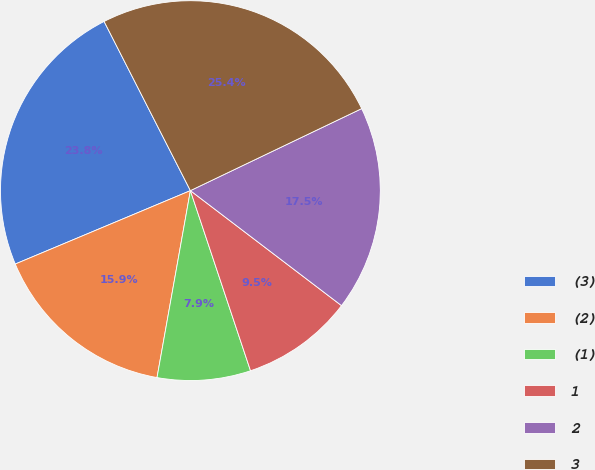<chart> <loc_0><loc_0><loc_500><loc_500><pie_chart><fcel>(3)<fcel>(2)<fcel>(1)<fcel>1<fcel>2<fcel>3<nl><fcel>23.81%<fcel>15.87%<fcel>7.94%<fcel>9.52%<fcel>17.46%<fcel>25.4%<nl></chart> 